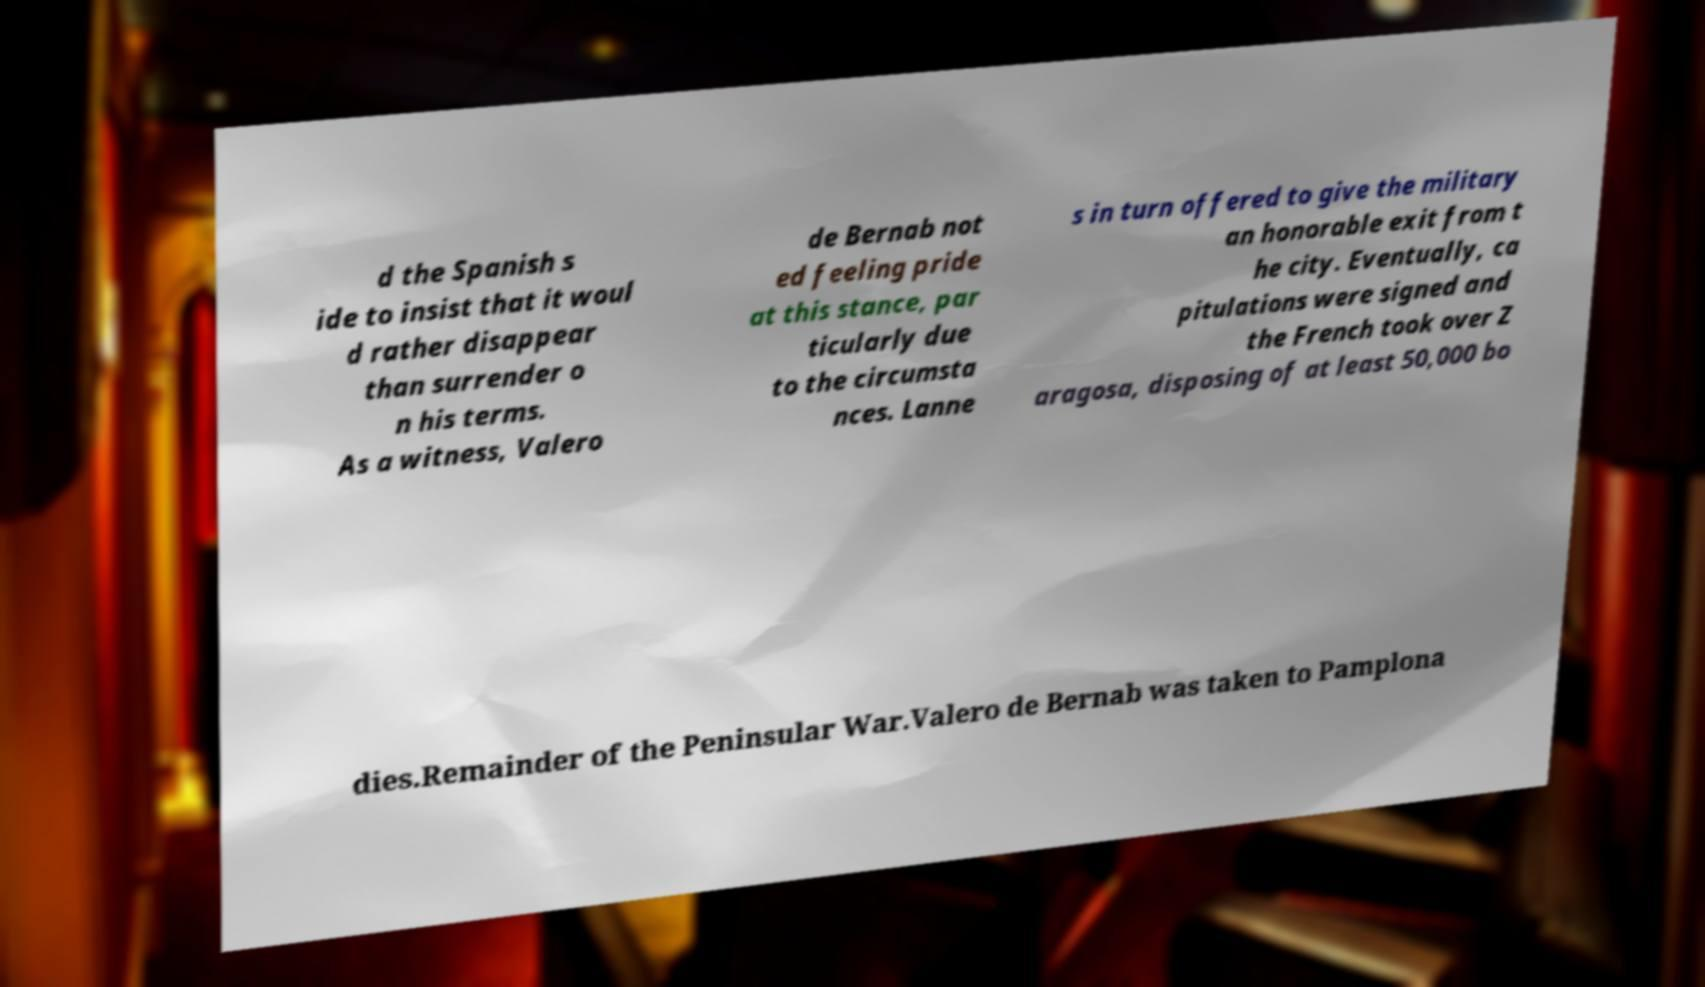Can you read and provide the text displayed in the image?This photo seems to have some interesting text. Can you extract and type it out for me? d the Spanish s ide to insist that it woul d rather disappear than surrender o n his terms. As a witness, Valero de Bernab not ed feeling pride at this stance, par ticularly due to the circumsta nces. Lanne s in turn offered to give the military an honorable exit from t he city. Eventually, ca pitulations were signed and the French took over Z aragosa, disposing of at least 50,000 bo dies.Remainder of the Peninsular War.Valero de Bernab was taken to Pamplona 